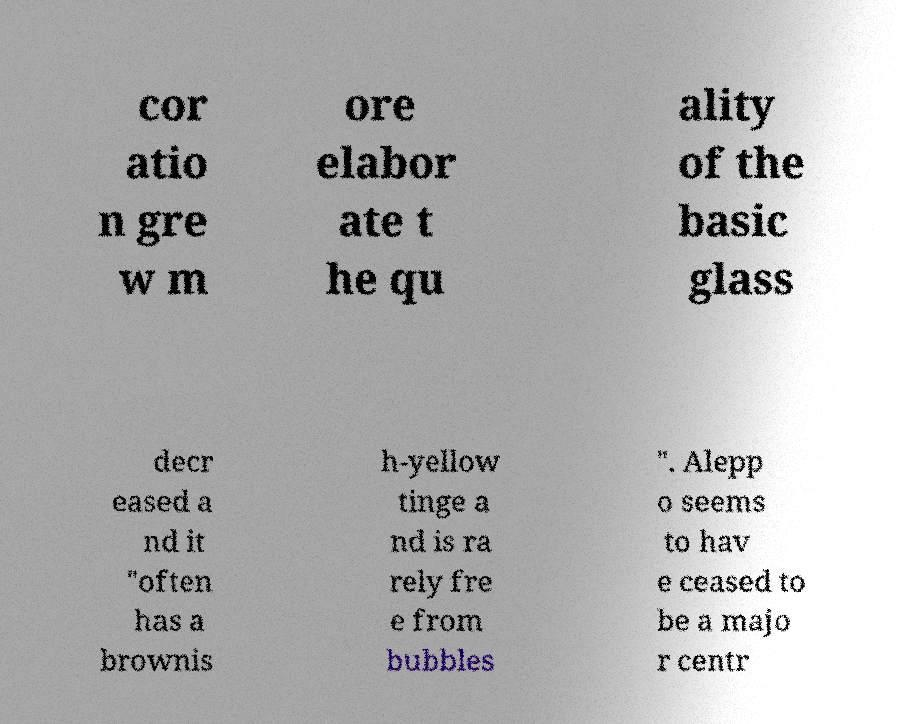I need the written content from this picture converted into text. Can you do that? cor atio n gre w m ore elabor ate t he qu ality of the basic glass decr eased a nd it "often has a brownis h-yellow tinge a nd is ra rely fre e from bubbles ". Alepp o seems to hav e ceased to be a majo r centr 